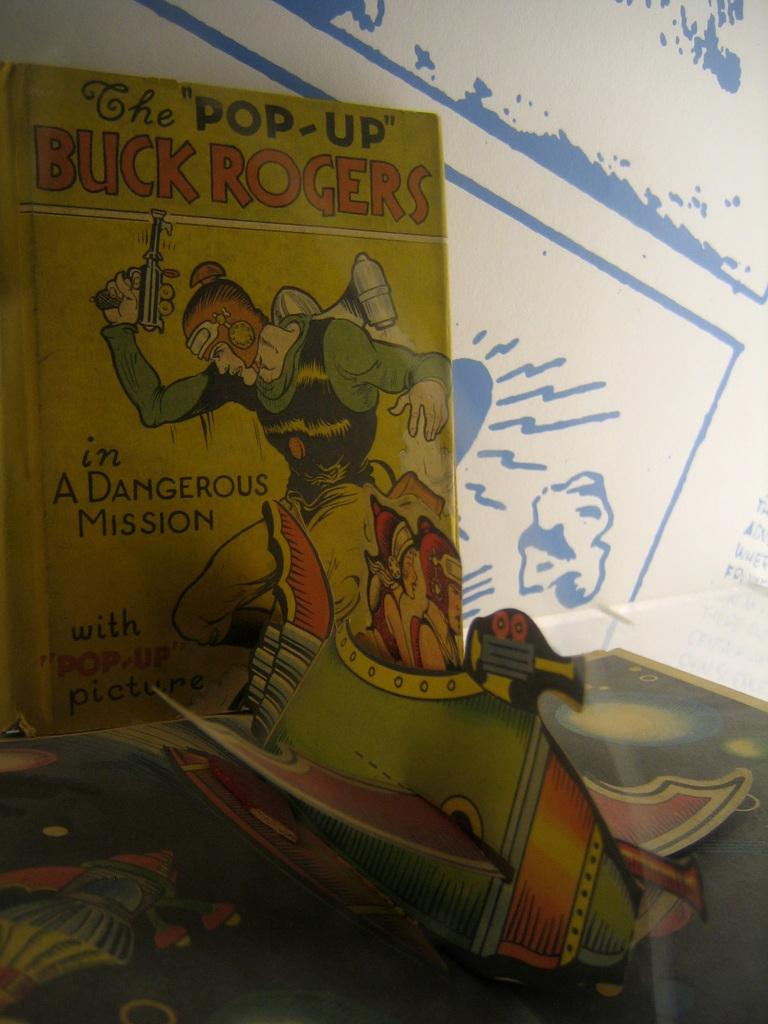What is featured on the poster in the image? The poster contains cartoons. What else can be found on the poster besides the cartoons? There is text on the poster. What time is displayed on the hour hand of the can in the image? There is no hour hand or can present in the image; it only features a poster with cartoons and text. 